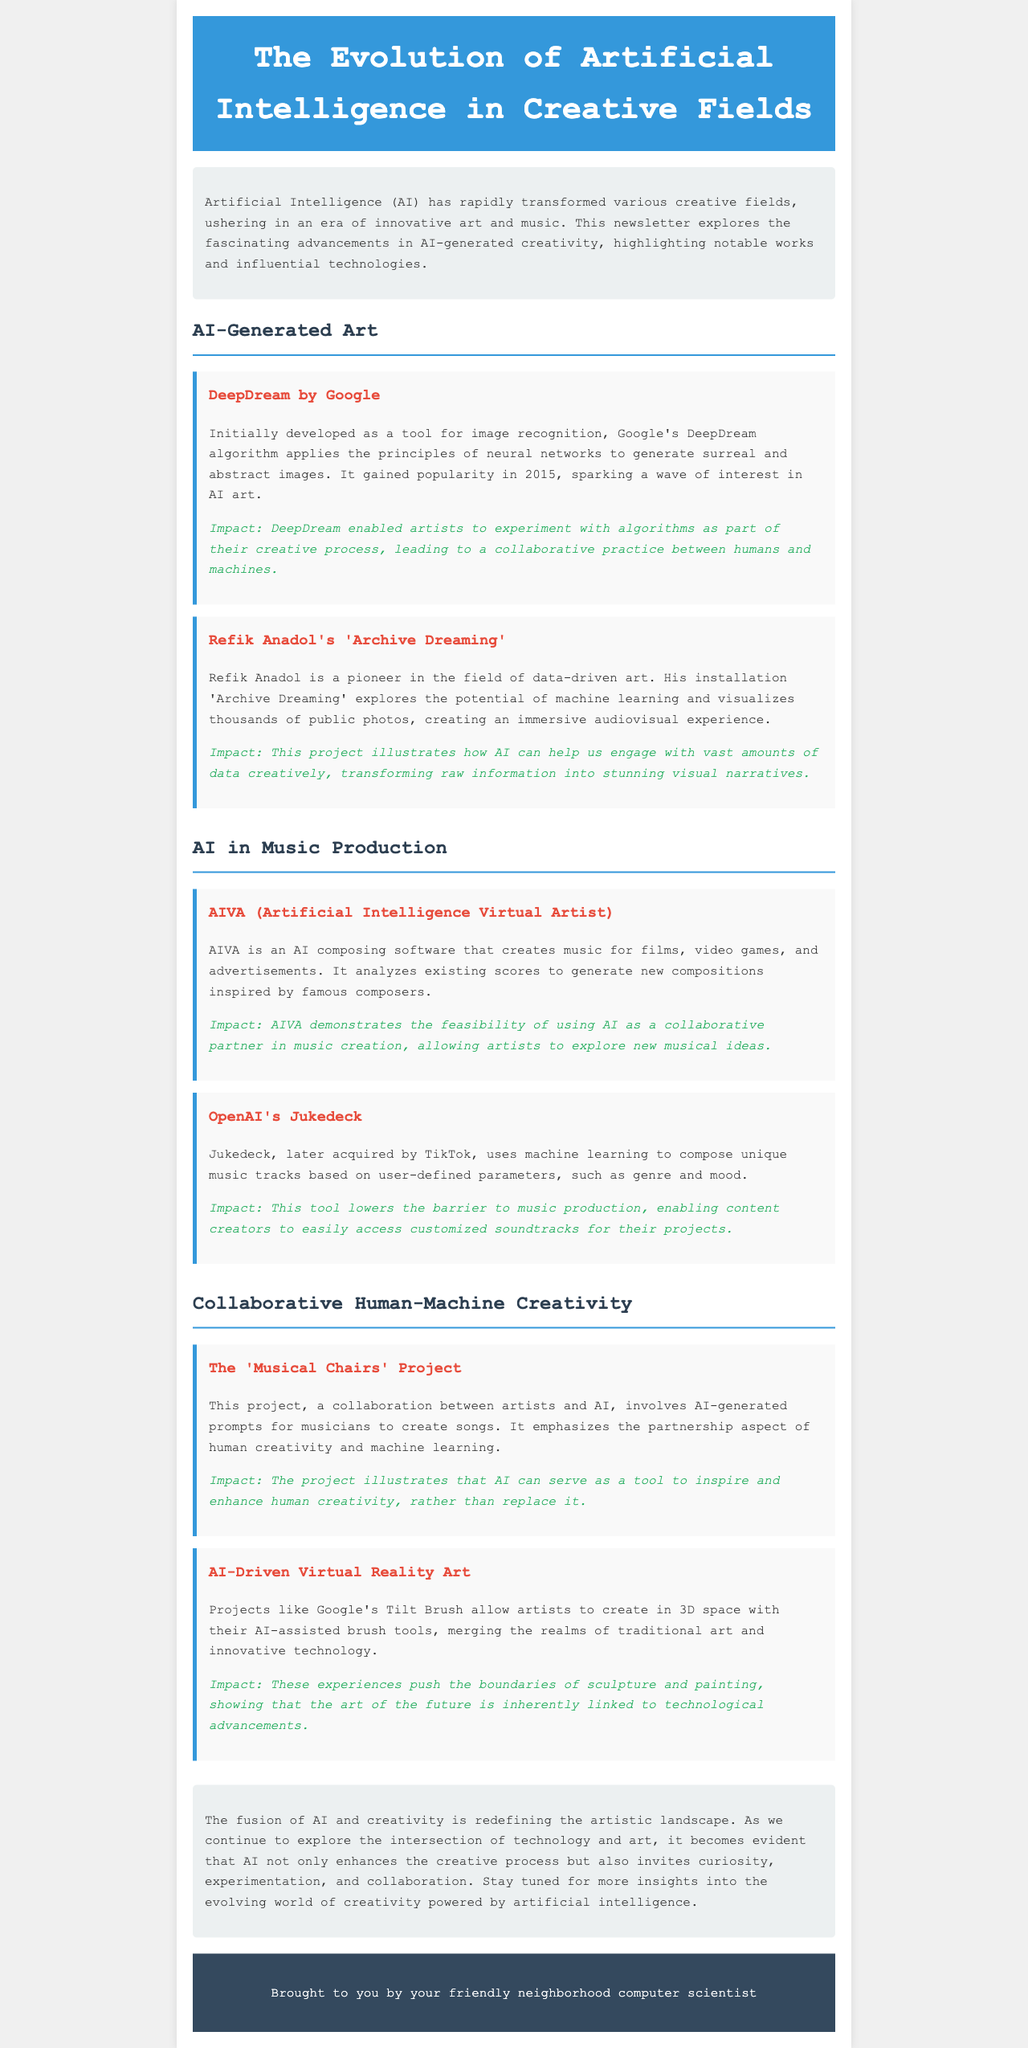What is the title of the newsletter? The title of the newsletter is prominently displayed at the top of the document, reflecting its focus on AI in creative fields.
Answer: The Evolution of Artificial Intelligence in Creative Fields Who developed DeepDream? DeepDream was developed by Google, as mentioned in the section discussing AI-generated art.
Answer: Google What is AIVA? AIVA is introduced in the music production section as an AI composing software that creates music.
Answer: AI composing software What type of project is 'Archive Dreaming'? 'Archive Dreaming' is described as an installation that utilizes machine learning and visualizes public photos.
Answer: Installation What impact does DeepDream have on artists? The impact statement concerning DeepDream indicates that it enabled artists to experiment with algorithms in their creative process.
Answer: Experiment with algorithms How does the 'Musical Chairs' Project emphasize creativity? The 'Musical Chairs' Project emphasizes creativity through its collaboration between artists and AI for generating song prompts.
Answer: Collaboration between artists and AI Which company acquired Jukedeck? The newsletter mentions that Jukedeck was acquired by TikTok, indicating corporate interest in music AI technologies.
Answer: TikTok What does Google's Tilt Brush allow artists to do? The document states that Tilt Brush allows artists to create in 3D space with AI-assisted brush tools.
Answer: Create in 3D space 